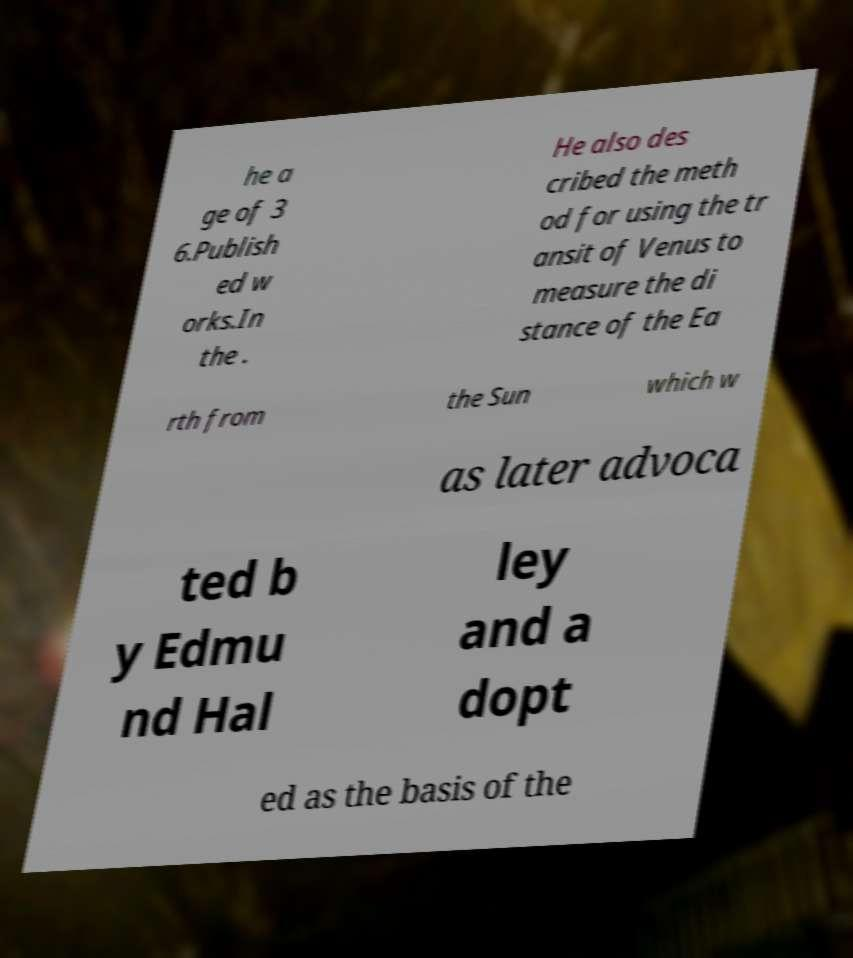Please read and relay the text visible in this image. What does it say? he a ge of 3 6.Publish ed w orks.In the . He also des cribed the meth od for using the tr ansit of Venus to measure the di stance of the Ea rth from the Sun which w as later advoca ted b y Edmu nd Hal ley and a dopt ed as the basis of the 